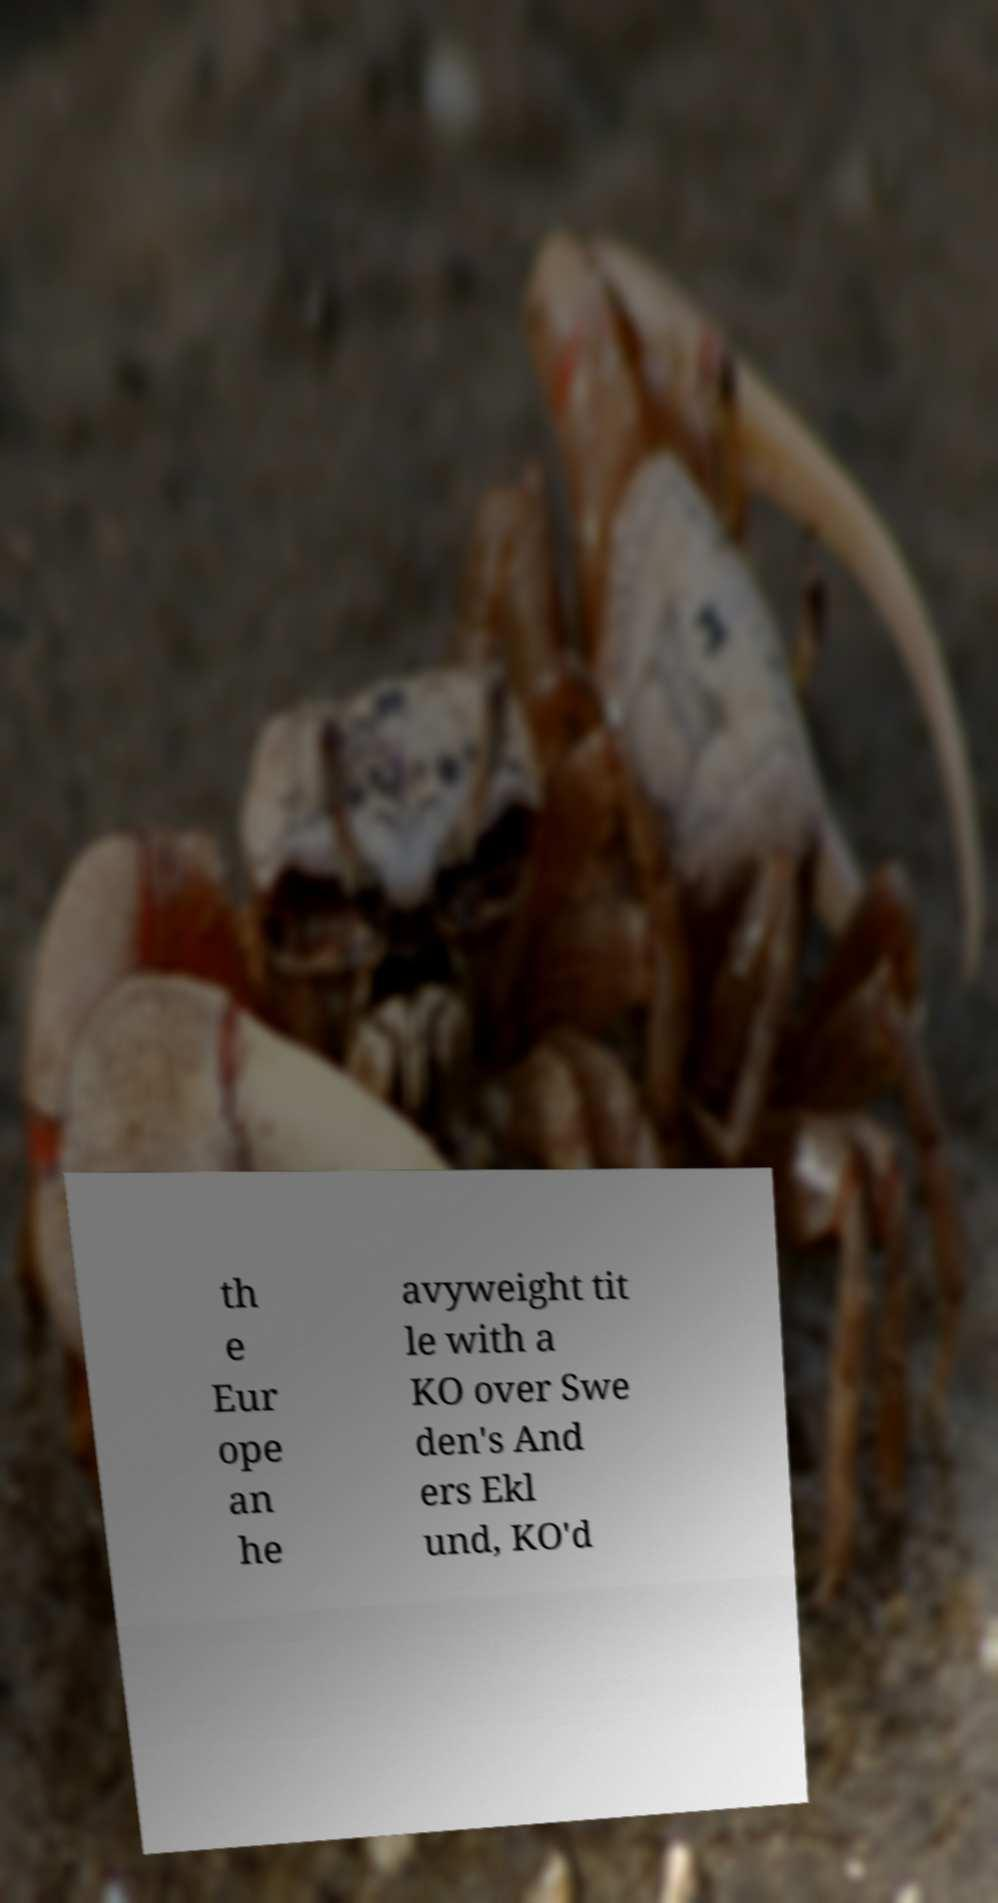Please identify and transcribe the text found in this image. th e Eur ope an he avyweight tit le with a KO over Swe den's And ers Ekl und, KO'd 